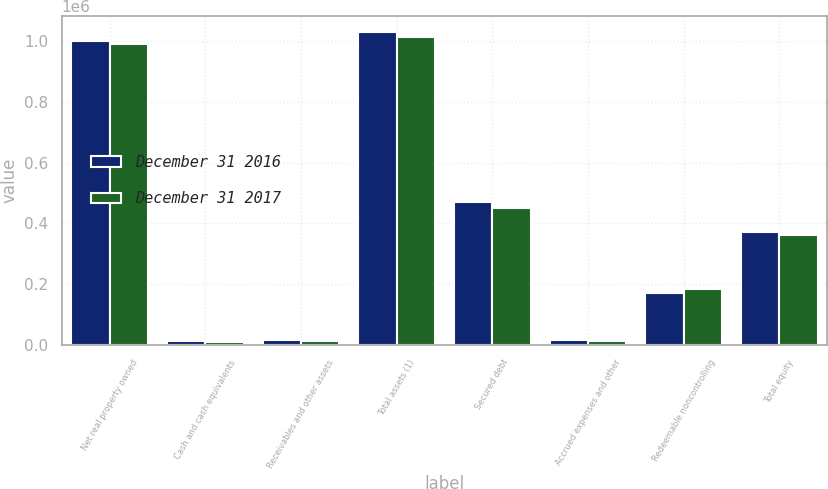<chart> <loc_0><loc_0><loc_500><loc_500><stacked_bar_chart><ecel><fcel>Net real property owned<fcel>Cash and cash equivalents<fcel>Receivables and other assets<fcel>Total assets (1)<fcel>Secured debt<fcel>Accrued expenses and other<fcel>Redeemable noncontrolling<fcel>Total equity<nl><fcel>December 31 2016<fcel>1.00214e+06<fcel>12308<fcel>16330<fcel>1.03078e+06<fcel>471103<fcel>14832<fcel>171898<fcel>372942<nl><fcel>December 31 2017<fcel>989596<fcel>10501<fcel>12102<fcel>1.0122e+06<fcel>450255<fcel>13803<fcel>185556<fcel>362585<nl></chart> 